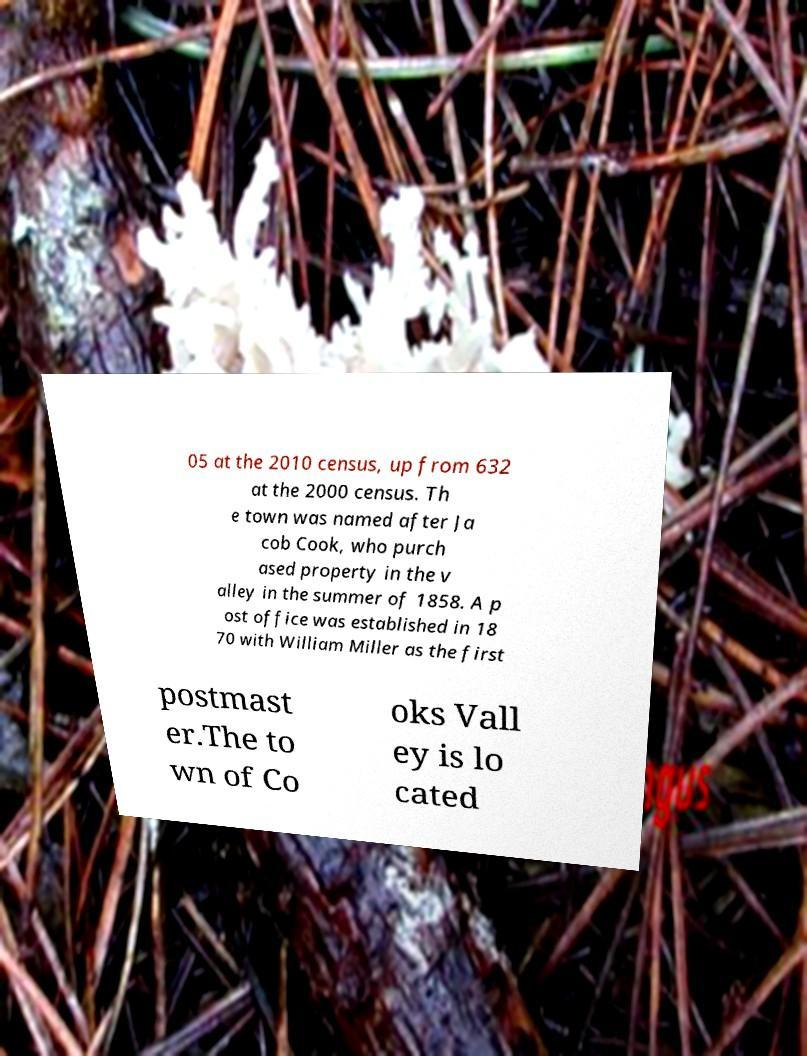For documentation purposes, I need the text within this image transcribed. Could you provide that? 05 at the 2010 census, up from 632 at the 2000 census. Th e town was named after Ja cob Cook, who purch ased property in the v alley in the summer of 1858. A p ost office was established in 18 70 with William Miller as the first postmast er.The to wn of Co oks Vall ey is lo cated 